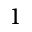<formula> <loc_0><loc_0><loc_500><loc_500>1</formula> 